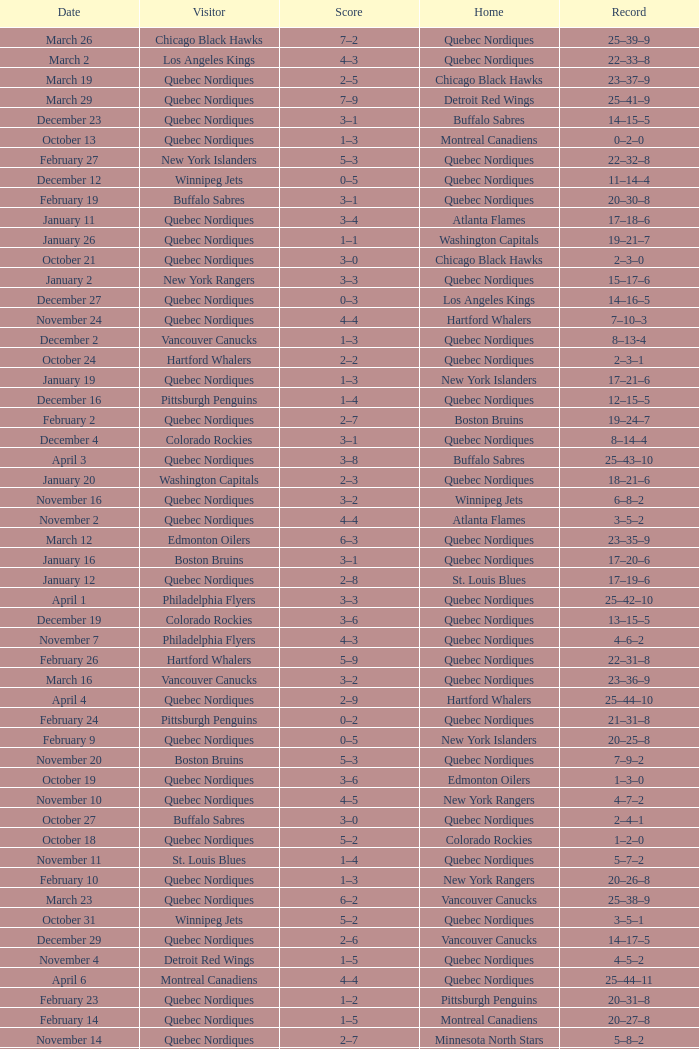Which Date has a Score of 2–7, and a Record of 5–8–2? November 14. 